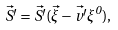<formula> <loc_0><loc_0><loc_500><loc_500>\vec { S ^ { \prime } } = \vec { S ^ { \prime } } ( \vec { \xi } - \vec { v ^ { \prime } } \xi ^ { 0 } ) ,</formula> 